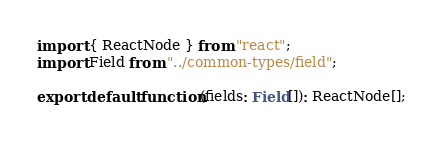<code> <loc_0><loc_0><loc_500><loc_500><_TypeScript_>import { ReactNode } from "react";
import Field from "../common-types/field";

export default function(fields: Field[]): ReactNode[];
</code> 